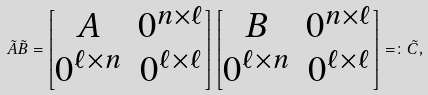<formula> <loc_0><loc_0><loc_500><loc_500>\tilde { A } \tilde { B } = \begin{bmatrix} A & 0 ^ { n \times \ell } \\ 0 ^ { \ell \times n } & 0 ^ { \ell \times \ell } \end{bmatrix} \begin{bmatrix} B & 0 ^ { n \times \ell } \\ 0 ^ { \ell \times n } & 0 ^ { \ell \times \ell } \end{bmatrix} = \colon \tilde { C } ,</formula> 